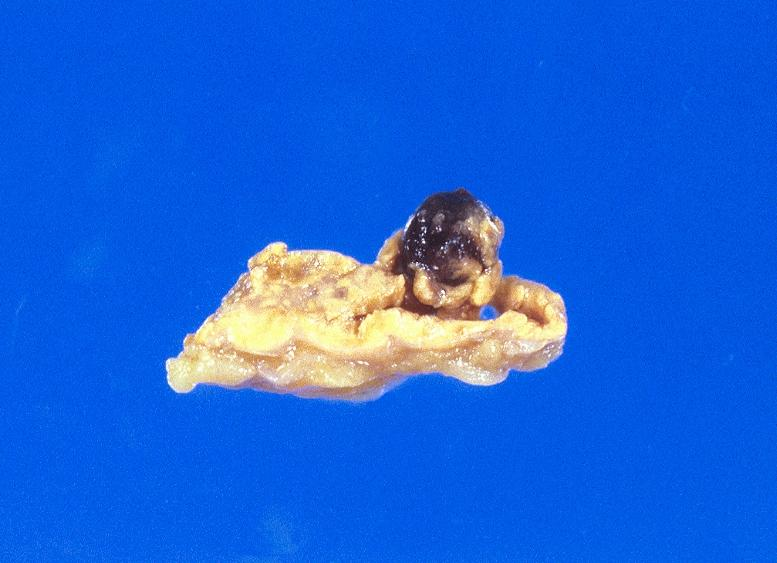what does this image show?
Answer the question using a single word or phrase. Malignant melanoma 